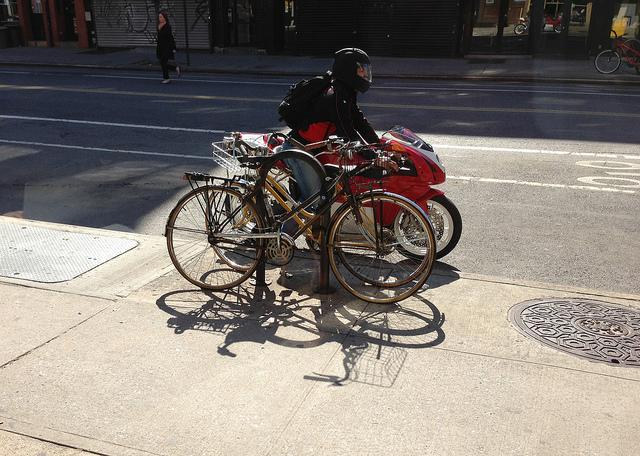In which lane does the person in the black helmet ride? bike lane 